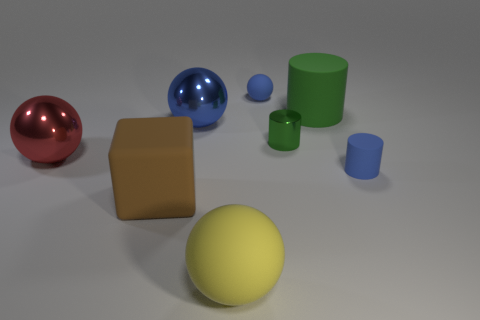Subtract all yellow spheres. How many spheres are left? 3 Subtract all small cylinders. How many cylinders are left? 1 Subtract all brown spheres. Subtract all red cylinders. How many spheres are left? 4 Add 1 cylinders. How many objects exist? 9 Subtract all blocks. How many objects are left? 7 Add 5 tiny green shiny objects. How many tiny green shiny objects are left? 6 Add 4 big purple rubber balls. How many big purple rubber balls exist? 4 Subtract 2 green cylinders. How many objects are left? 6 Subtract all red metal spheres. Subtract all small blue matte balls. How many objects are left? 6 